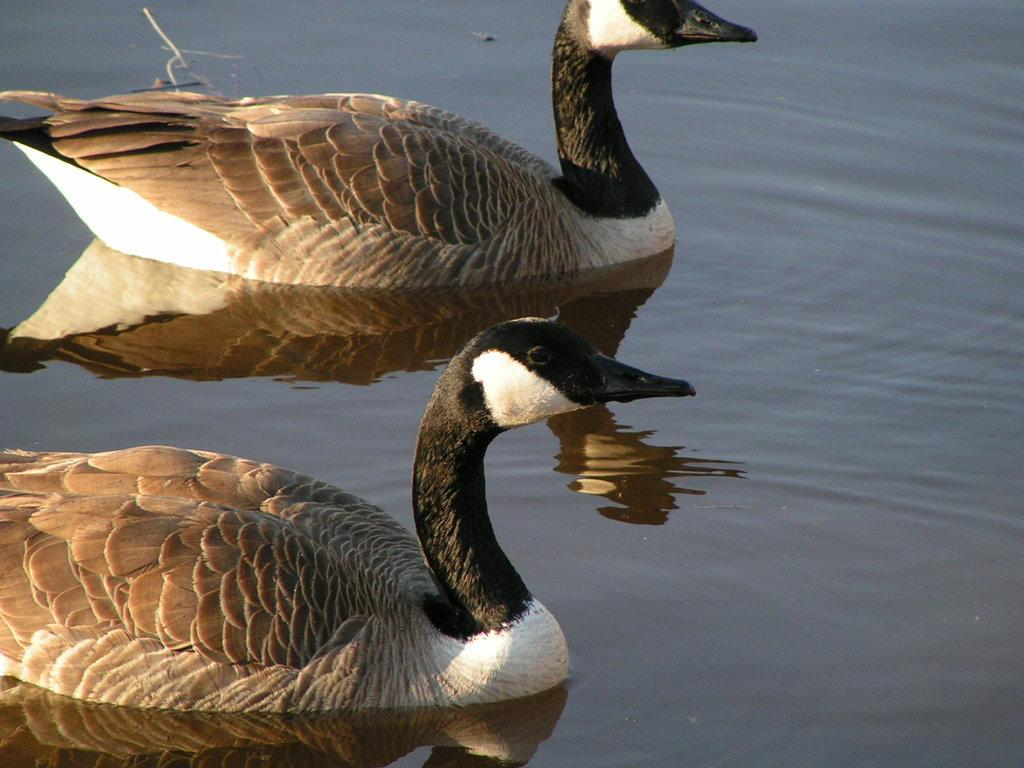What animals can be seen in the water in the foreground of the image? There are ducks in the water in the foreground of the image. Can you describe the setting of the image? The image features ducks in the water, which suggests a natural environment such as a pond or lake. What statement is being made by the ducks in the image? There is no statement being made by the ducks in the image; they are simply swimming in the water. 